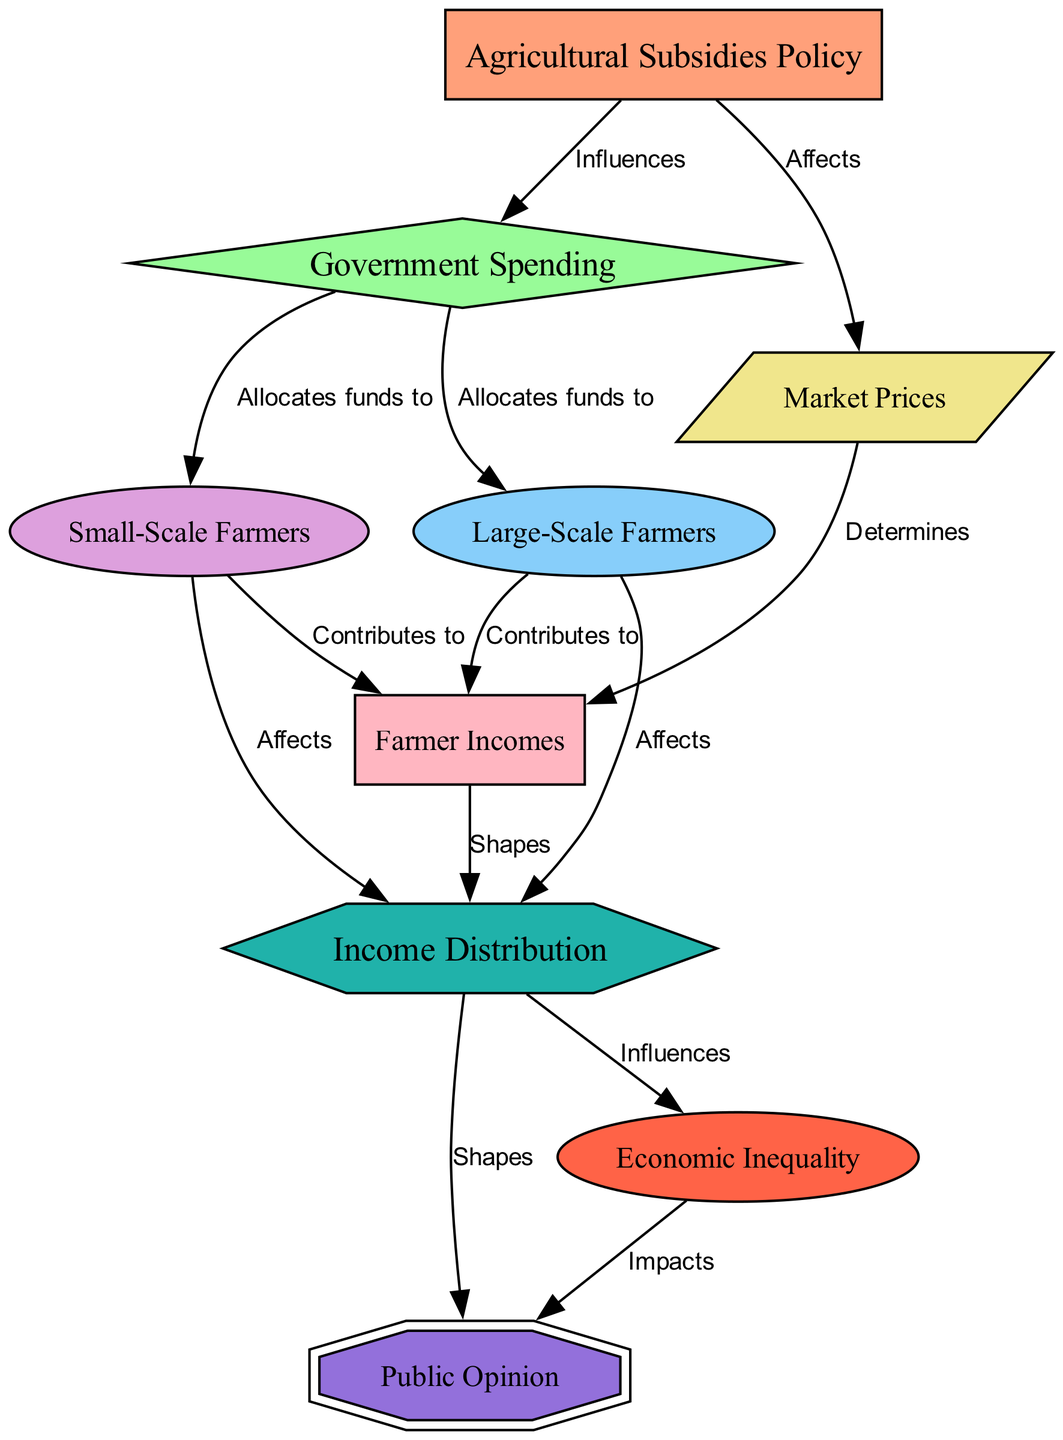What is the relationship between subsidies policy and government spending? The diagram shows that the subsidies policy directly influences government spending, indicated by the edge labeled "Influences" that connects the subsidies policy node to the government spending node.
Answer: Influences How many farmers are represented in the diagram? The diagram includes two types of farmers: large-scale farmers and small-scale farmers, as indicated by the distinct nodes for each. Therefore, there are two categories of farmers represented.
Answer: Two What aspect does market prices affect according to the diagram? The diagram illustrates that market prices affect farm incomes, as indicated by the edge labeled "Determines" connecting the market prices node to the farm incomes node.
Answer: Farm incomes What do large-scale farmers contribute to? According to the diagram, large-scale farmers contribute to farm incomes, as represented by the edge labeled "Contributes to" from the large-scale farmers node to the farm incomes node.
Answer: Farm incomes How does income distribution impact public opinion? The relationship is shown in the diagram with an edge labeled "Shapes" connecting income distribution to public opinion, indicating that the way income is distributed has an effect on public opinion.
Answer: Shapes What type of farmers are allocated funds by government spending? The government spending node is connected by edges labeled "Allocates funds to" to both large-scale farmers and small-scale farmers, indicating that both types of farmers receive funds.
Answer: Both What influences economic inequality according to the diagram? The diagram indicates that income distribution influences economic inequality, as shown by the edge labeled "Influences" connecting the income distribution node to the economic inequality node.
Answer: Income distribution What is the impact of economic inequality on public opinion? The diagram shows that economic inequality impacts public opinion, with an edge labeled "Impacts" connecting the economic inequality node to the public opinion node.
Answer: Impacts How does the agricultural subsidies policy affect market prices? The diagram directly states that the agricultural subsidies policy affects market prices, illustrated by the edge labeled "Affects" connecting these two nodes.
Answer: Affects 